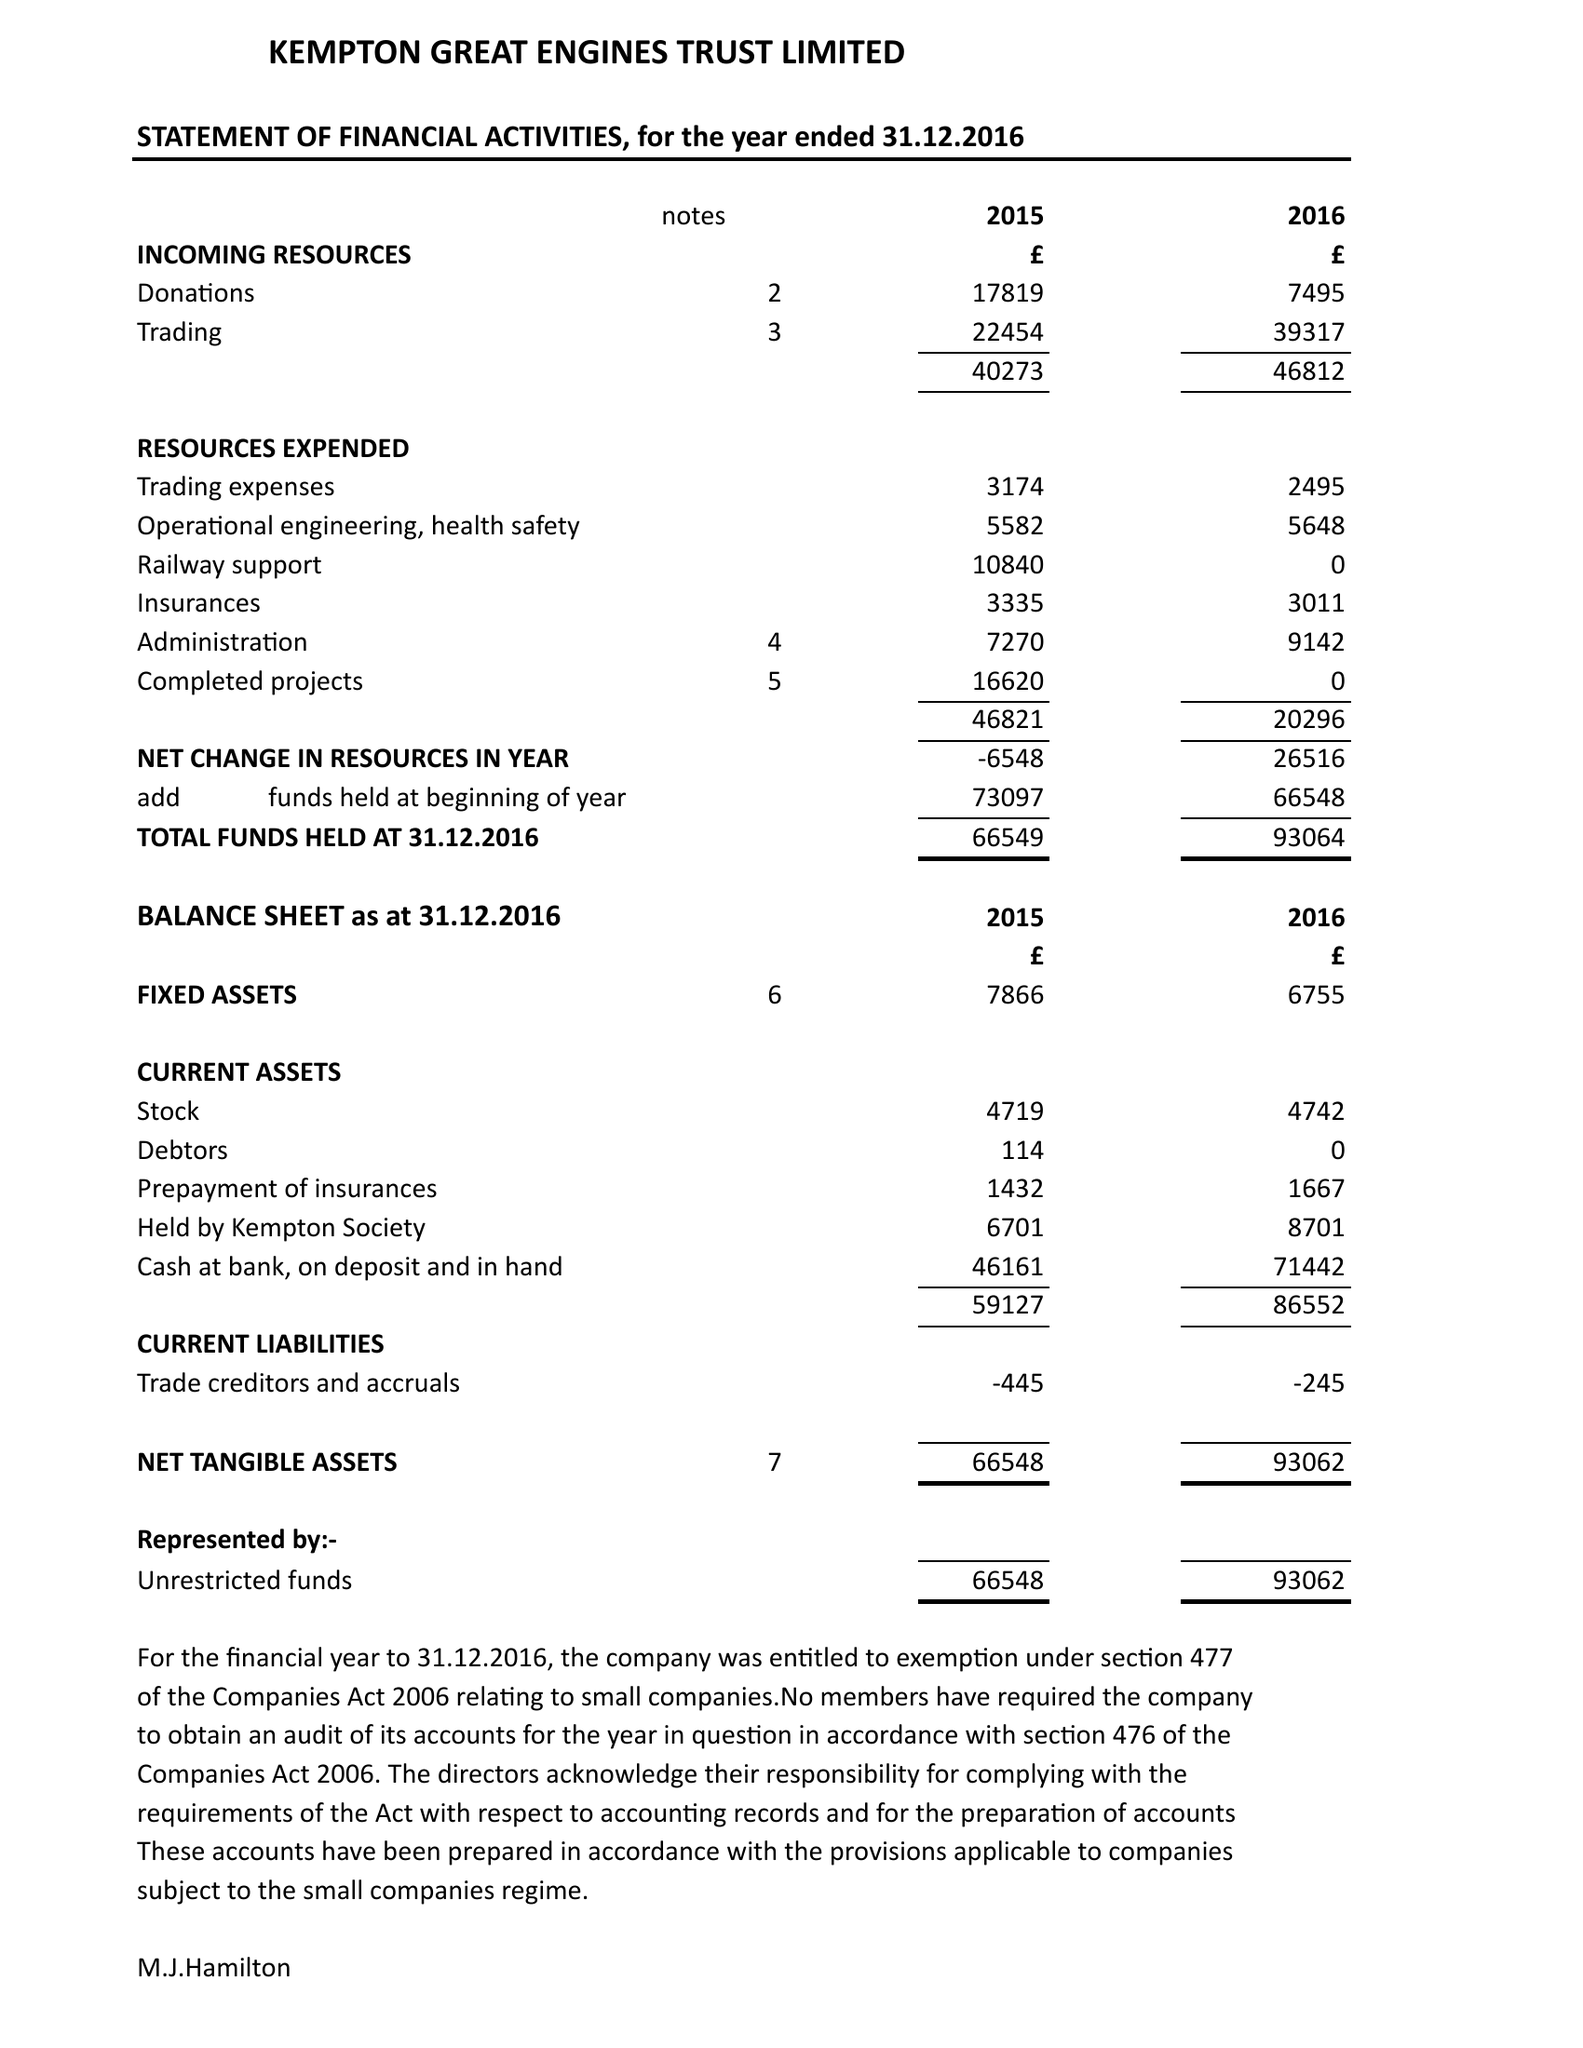What is the value for the charity_name?
Answer the question using a single word or phrase. Kempton Great Engines Trust Ltd. 